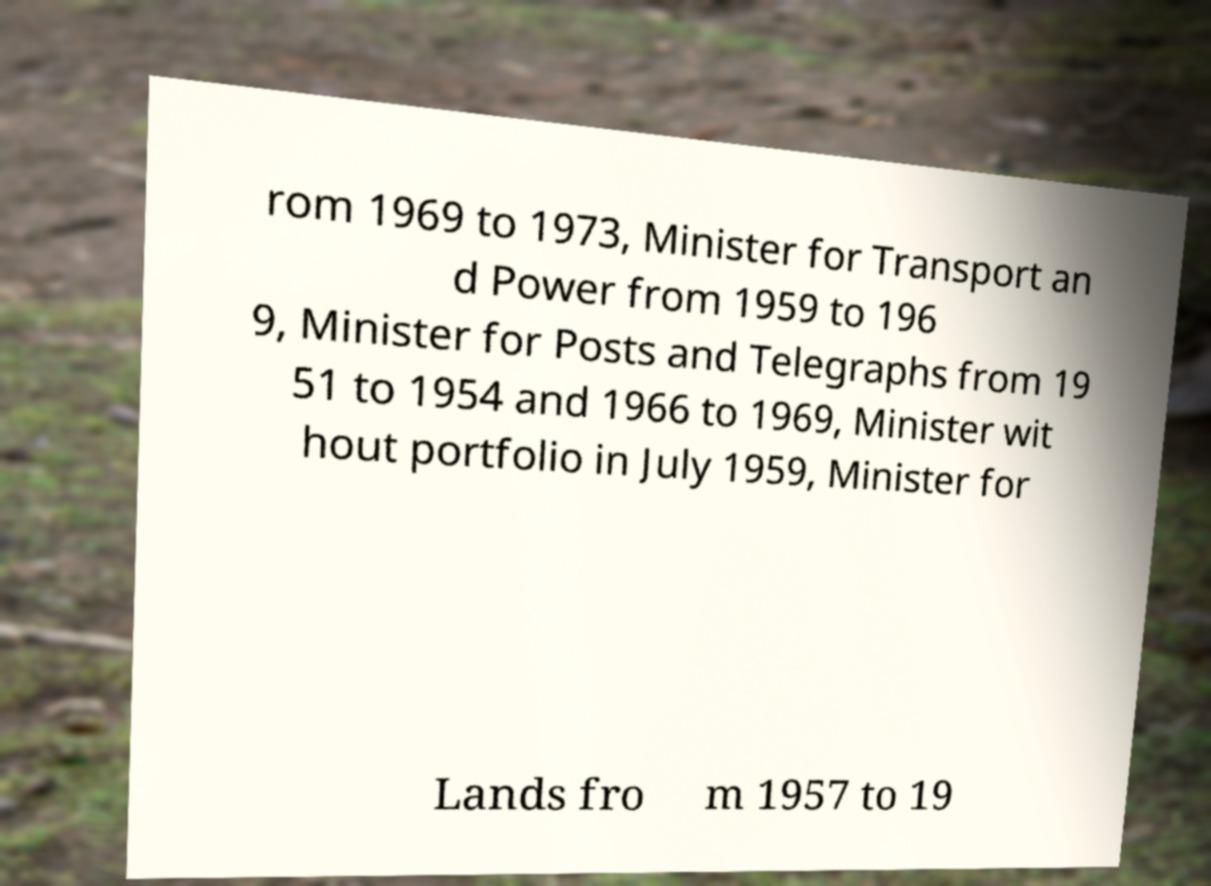Can you accurately transcribe the text from the provided image for me? rom 1969 to 1973, Minister for Transport an d Power from 1959 to 196 9, Minister for Posts and Telegraphs from 19 51 to 1954 and 1966 to 1969, Minister wit hout portfolio in July 1959, Minister for Lands fro m 1957 to 19 